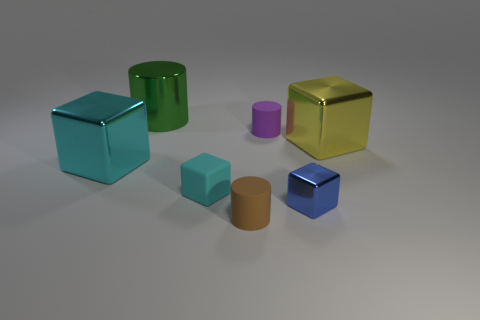Are there any other tiny cylinders of the same color as the metal cylinder?
Ensure brevity in your answer.  No. What size is the blue cube that is the same material as the large cylinder?
Ensure brevity in your answer.  Small. Is the number of cyan rubber cubes right of the big yellow shiny cube greater than the number of tiny brown cylinders on the right side of the brown object?
Your response must be concise. No. What number of other objects are the same material as the blue cube?
Keep it short and to the point. 3. Is the big object to the right of the tiny blue shiny block made of the same material as the tiny brown cylinder?
Your answer should be very brief. No. What is the shape of the blue shiny thing?
Give a very brief answer. Cube. Is the number of large objects right of the cyan metal object greater than the number of small brown rubber cubes?
Provide a short and direct response. Yes. Are there any other things that have the same shape as the tiny cyan object?
Your response must be concise. Yes. There is another tiny thing that is the same shape as the small brown object; what is its color?
Give a very brief answer. Purple. There is a metal thing in front of the cyan matte block; what shape is it?
Keep it short and to the point. Cube. 